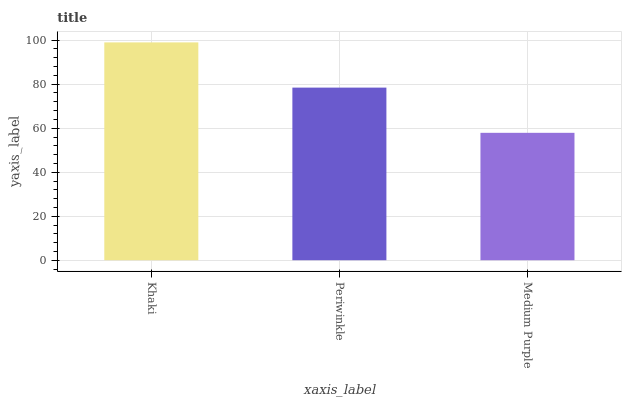Is Periwinkle the minimum?
Answer yes or no. No. Is Periwinkle the maximum?
Answer yes or no. No. Is Khaki greater than Periwinkle?
Answer yes or no. Yes. Is Periwinkle less than Khaki?
Answer yes or no. Yes. Is Periwinkle greater than Khaki?
Answer yes or no. No. Is Khaki less than Periwinkle?
Answer yes or no. No. Is Periwinkle the high median?
Answer yes or no. Yes. Is Periwinkle the low median?
Answer yes or no. Yes. Is Medium Purple the high median?
Answer yes or no. No. Is Khaki the low median?
Answer yes or no. No. 